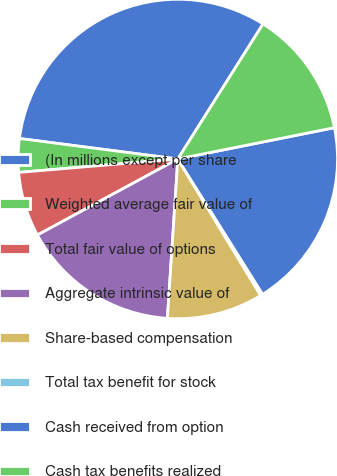Convert chart to OTSL. <chart><loc_0><loc_0><loc_500><loc_500><pie_chart><fcel>(In millions except per share<fcel>Weighted average fair value of<fcel>Total fair value of options<fcel>Aggregate intrinsic value of<fcel>Share-based compensation<fcel>Total tax benefit for stock<fcel>Cash received from option<fcel>Cash tax benefits realized<nl><fcel>31.91%<fcel>3.39%<fcel>6.56%<fcel>16.06%<fcel>9.73%<fcel>0.22%<fcel>19.23%<fcel>12.9%<nl></chart> 